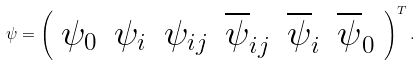Convert formula to latex. <formula><loc_0><loc_0><loc_500><loc_500>\psi = \left ( \begin{array} { c c c c c c } \psi _ { 0 } & \psi _ { i } & \psi _ { i j } & \overline { \psi } _ { i j } & \overline { \psi } _ { i } & \overline { \psi } _ { 0 } \end{array} \right ) ^ { T } .</formula> 